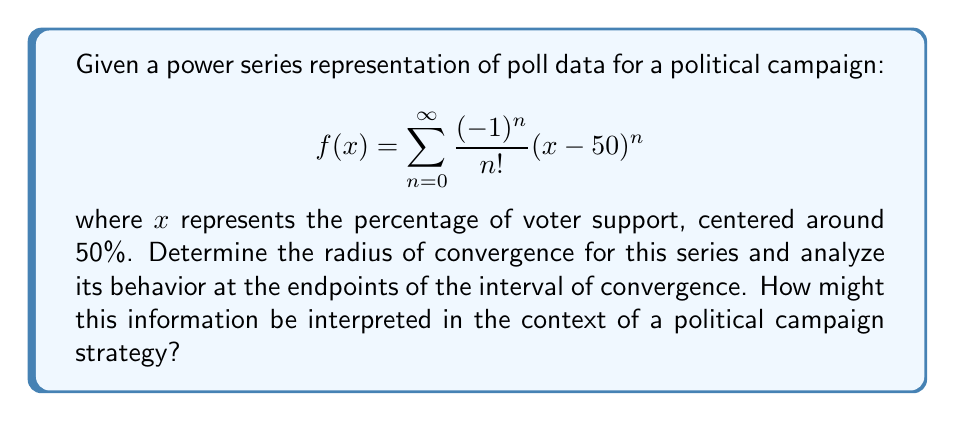Can you solve this math problem? To analyze the convergence of this power series, we'll follow these steps:

1) First, we need to find the radius of convergence. We can use the ratio test:

   $$\lim_{n \to \infty} \left|\frac{a_{n+1}}{a_n}\right| = \lim_{n \to \infty} \left|\frac{(-1)^{n+1}}{(n+1)!} \cdot \frac{n!}{(-1)^n}\right| = \lim_{n \to \infty} \frac{1}{n+1} = 0$$

   Since this limit is 0, which is less than 1, the series converges for all $x$. Therefore, the radius of convergence is infinity.

2) Given that the radius of convergence is infinite, the interval of convergence is $(-\infty, \infty)$. There are no endpoints to consider.

3) We can recognize this series as the Taylor series for $e^{-(x-50)}$ centered at $x=50$:

   $$f(x) = e^{-(x-50)} = e^{50-x}$$

4) Interpreting this in the context of a political campaign:

   - The function decays exponentially as $x$ moves away from 50 in either direction.
   - At $x=50$, $f(50) = e^0 = 1$, representing peak support.
   - As $x$ increases above 50, $f(x)$ decreases rapidly, suggesting diminishing returns for additional support gained.
   - As $x$ decreases below 50, $f(x)$ increases exponentially, potentially indicating the difficulty of recovering from low poll numbers.

5) This analysis suggests that maintaining support close to 50% is crucial, as deviations can lead to rapid changes in the campaign's position. It also highlights the challenges of recovering from low poll numbers and the diminishing returns of extremely high poll numbers.
Answer: The radius of convergence is infinite, and the series converges for all real $x$. The function represented by the series is $f(x) = e^{50-x}$, which decays exponentially as $x$ moves away from 50 in either direction. This suggests that maintaining poll numbers close to 50% is critical for campaign stability, with rapid changes possible for small deviations from this central value. 